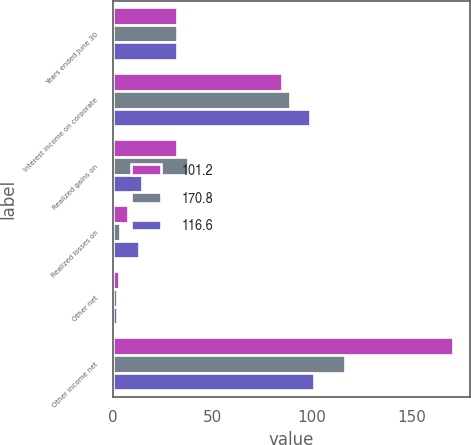Convert chart. <chart><loc_0><loc_0><loc_500><loc_500><stacked_bar_chart><ecel><fcel>Years ended June 30<fcel>Interest income on corporate<fcel>Realized gains on<fcel>Realized losses on<fcel>Other net<fcel>Other income net<nl><fcel>101.2<fcel>32.1<fcel>85.2<fcel>32.1<fcel>7.7<fcel>3.2<fcel>170.8<nl><fcel>170.8<fcel>32.1<fcel>88.8<fcel>38<fcel>3.6<fcel>2.4<fcel>116.6<nl><fcel>116.6<fcel>32.1<fcel>98.8<fcel>15<fcel>13.4<fcel>2.3<fcel>101.2<nl></chart> 